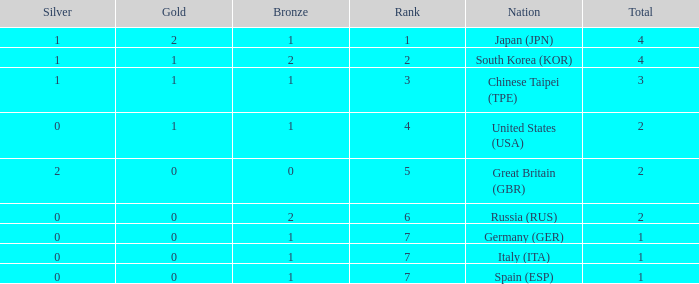What is the rank of the country with more than 2 medals, and 2 gold medals? 1.0. 